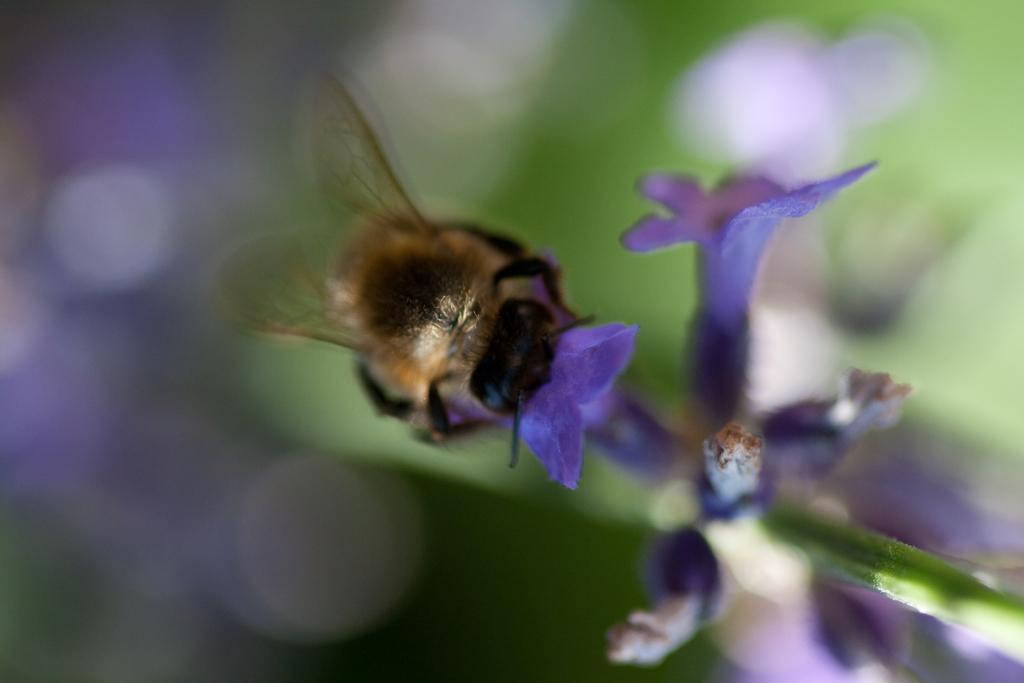What is the main subject of the image? There is an insect in the image. Where is the insect located? The insect is on a flower. Can you describe the background of the image? The background of the image is blurred. What is the cause of the discussion among the animals on the farm in the image? There is no discussion among animals on a farm in the image, as the image only features an insect on a flower with a blurred background. 